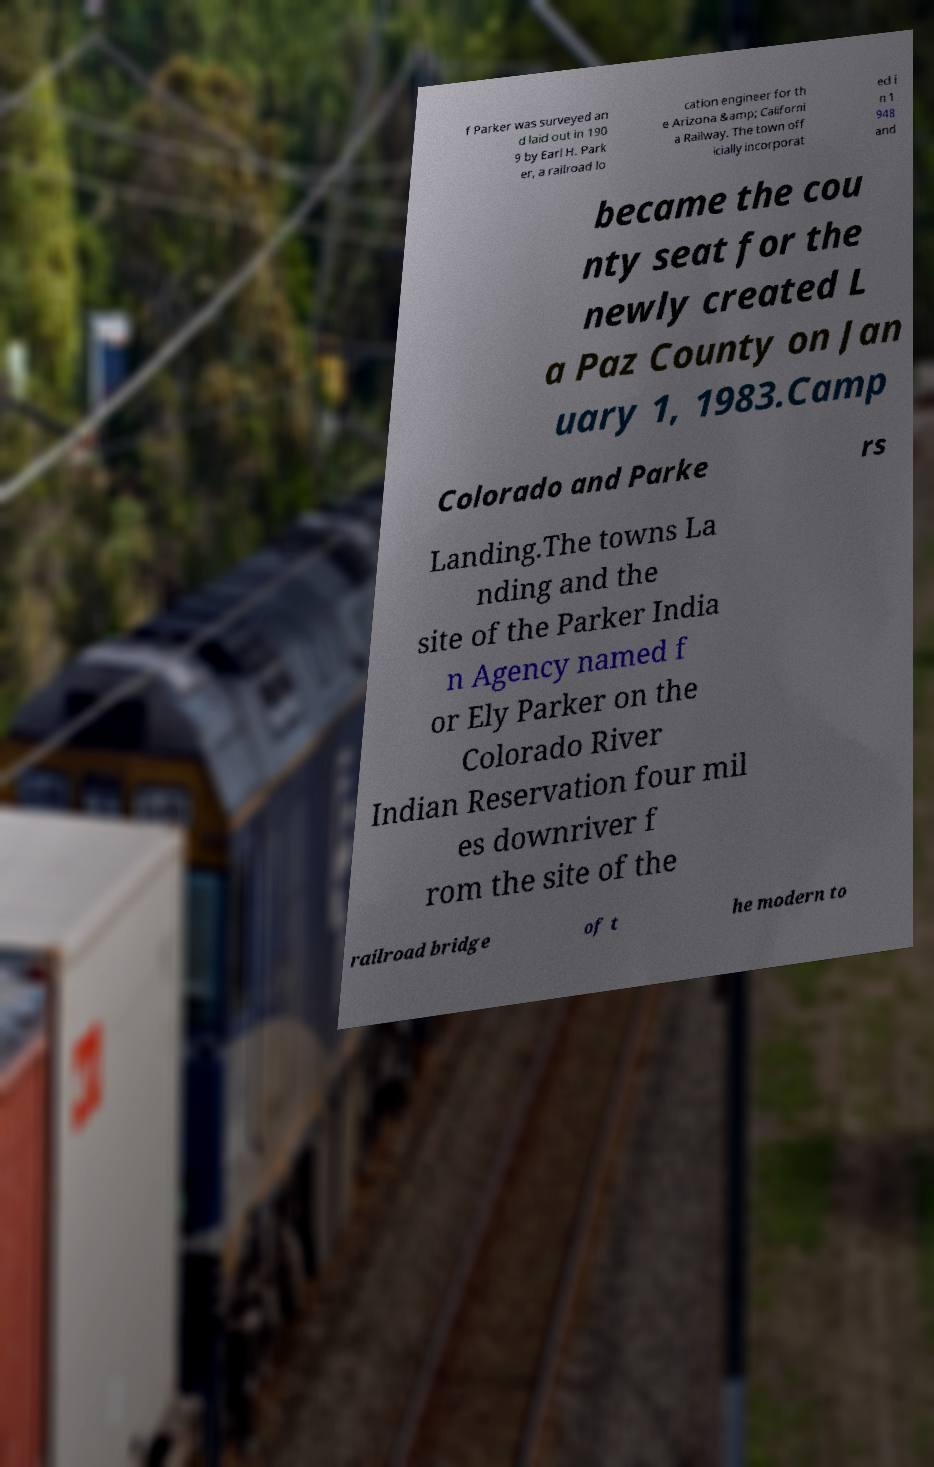There's text embedded in this image that I need extracted. Can you transcribe it verbatim? f Parker was surveyed an d laid out in 190 9 by Earl H. Park er, a railroad lo cation engineer for th e Arizona &amp; Californi a Railway. The town off icially incorporat ed i n 1 948 and became the cou nty seat for the newly created L a Paz County on Jan uary 1, 1983.Camp Colorado and Parke rs Landing.The towns La nding and the site of the Parker India n Agency named f or Ely Parker on the Colorado River Indian Reservation four mil es downriver f rom the site of the railroad bridge of t he modern to 